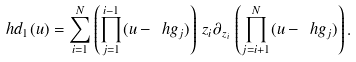<formula> <loc_0><loc_0><loc_500><loc_500>\ h d _ { 1 } ( u ) = \sum _ { i = 1 } ^ { N } \left ( \prod _ { j = 1 } ^ { i - 1 } ( u - \ h g _ { j } ) \right ) \, z _ { i } \partial _ { z _ { i } } \, \left ( \prod _ { j = i + 1 } ^ { N } ( u - \ h g _ { j } ) \right ) .</formula> 